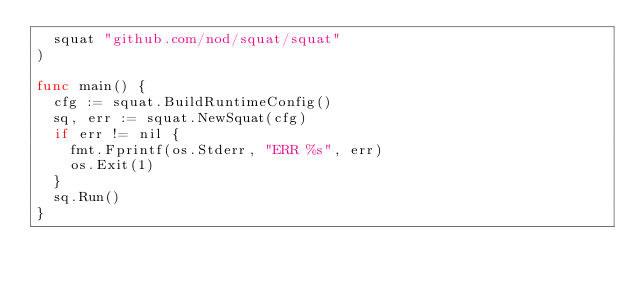Convert code to text. <code><loc_0><loc_0><loc_500><loc_500><_Go_>	squat "github.com/nod/squat/squat"
)

func main() {
	cfg := squat.BuildRuntimeConfig()
	sq, err := squat.NewSquat(cfg)
	if err != nil {
		fmt.Fprintf(os.Stderr, "ERR %s", err)
		os.Exit(1)
	}
	sq.Run()
}
</code> 